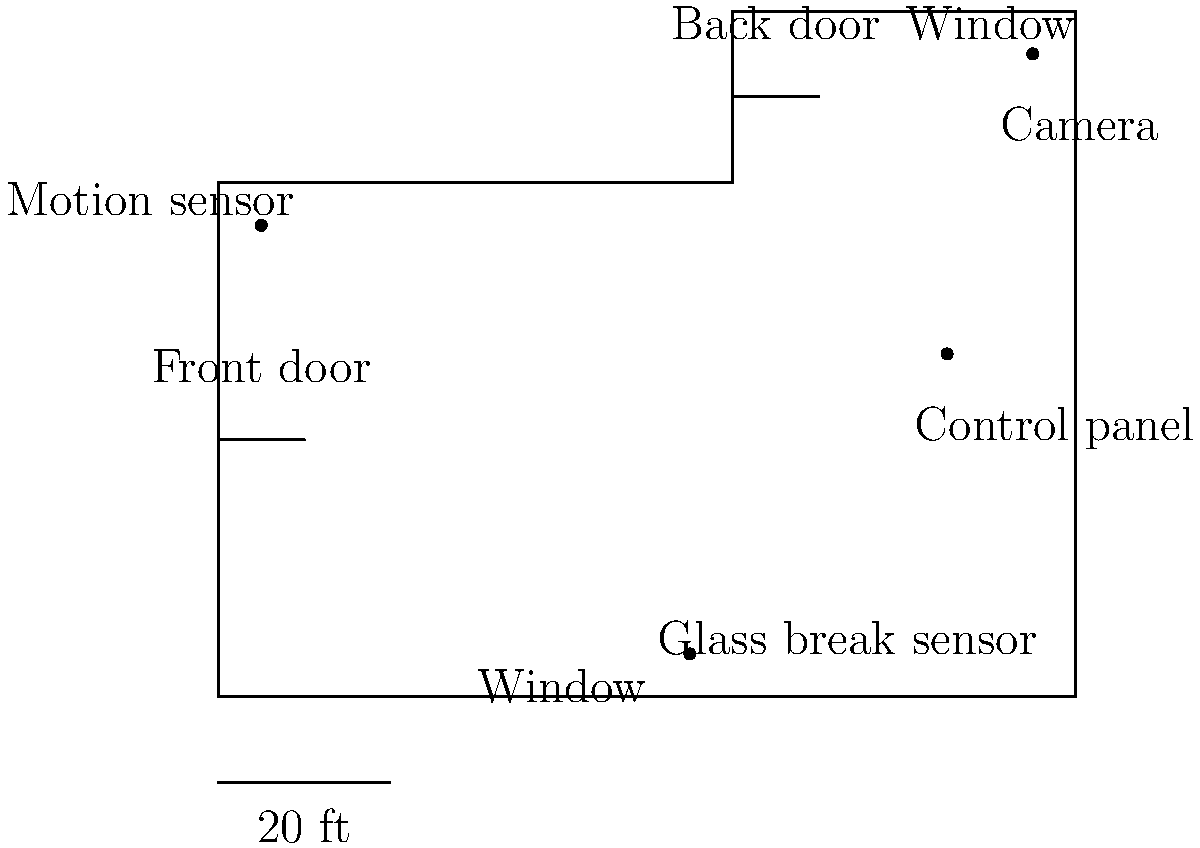Given the floor plan and sensor placement shown in the diagram, which additional security measure would be most effective in addressing the vulnerabilities of this home security system layout? To answer this question, we need to analyze the current security system layout and identify potential vulnerabilities:

1. Current security measures:
   - Motion sensor near the front door
   - Camera covering the back door and window
   - Glass break sensor near the front window
   - Control panel in the center of the house

2. Vulnerabilities:
   a. The front door area is only covered by a motion sensor, which may not detect an intruder if they enter slowly or stay close to the walls.
   b. The front window has a glass break sensor, but no camera coverage.
   c. The back door and window are covered by a camera, but lack motion detection.
   d. There are no sensors or cameras covering the left side of the house.

3. Potential improvements:
   a. Adding a camera near the front door would provide visual coverage of the main entry point.
   b. Installing a motion sensor near the back door would complement the camera coverage.
   c. Adding sensors or cameras to the left side of the house would eliminate the blind spot.
   d. Installing a smart doorbell with a camera at the front door would provide additional security and allow for remote monitoring.

4. Most effective improvement:
   Considering the persona of a single mother trying to protect her children from negative influences, the most effective additional measure would be installing a smart doorbell with a camera at the front door. This would:
   - Provide visual coverage of the main entry point
   - Allow for remote monitoring and two-way communication
   - Act as a deterrent to potential intruders
   - Enable the mother to screen visitors before opening the door, enhancing her children's safety

This solution addresses the main vulnerability (lack of visual coverage at the front door) while providing additional benefits that align with the mother's need to protect her children.
Answer: Install a smart doorbell with a camera at the front door. 